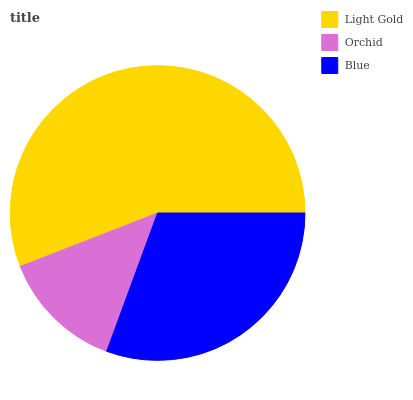Is Orchid the minimum?
Answer yes or no. Yes. Is Light Gold the maximum?
Answer yes or no. Yes. Is Blue the minimum?
Answer yes or no. No. Is Blue the maximum?
Answer yes or no. No. Is Blue greater than Orchid?
Answer yes or no. Yes. Is Orchid less than Blue?
Answer yes or no. Yes. Is Orchid greater than Blue?
Answer yes or no. No. Is Blue less than Orchid?
Answer yes or no. No. Is Blue the high median?
Answer yes or no. Yes. Is Blue the low median?
Answer yes or no. Yes. Is Light Gold the high median?
Answer yes or no. No. Is Orchid the low median?
Answer yes or no. No. 